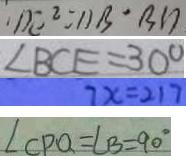Convert formula to latex. <formula><loc_0><loc_0><loc_500><loc_500>D E ^ { 2 } = 1 1 B ^ { \prime } B D 
 \angle B C E = 3 0 ^ { \circ } 
 7 x = 2 1 7 
 \angle C P Q = \angle B = 9 0 ^ { \circ }</formula> 